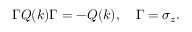<formula> <loc_0><loc_0><loc_500><loc_500>\Gamma Q ( k ) \Gamma = - Q ( k ) , \quad \Gamma = \sigma _ { z } .</formula> 